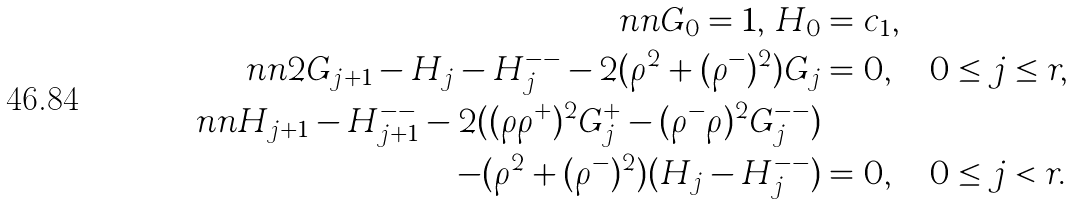Convert formula to latex. <formula><loc_0><loc_0><loc_500><loc_500>\ n n G _ { 0 } = 1 , \, H _ { 0 } & = c _ { 1 } , \\ \ n n 2 G _ { j + 1 } - H _ { j } - H _ { j } ^ { - - } - 2 ( \rho ^ { 2 } + ( \rho ^ { - } ) ^ { 2 } ) G _ { j } & = 0 , \quad 0 \leq j \leq r , \\ \ n n H _ { j + 1 } - H _ { j + 1 } ^ { - - } - 2 ( ( \rho \rho ^ { + } ) ^ { 2 } G _ { j } ^ { + } - ( \rho ^ { - } \rho ) ^ { 2 } G _ { j } ^ { - - } ) & \\ - ( \rho ^ { 2 } + ( \rho ^ { - } ) ^ { 2 } ) ( H _ { j } - H _ { j } ^ { - - } ) & = 0 , \quad 0 \leq j < r .</formula> 